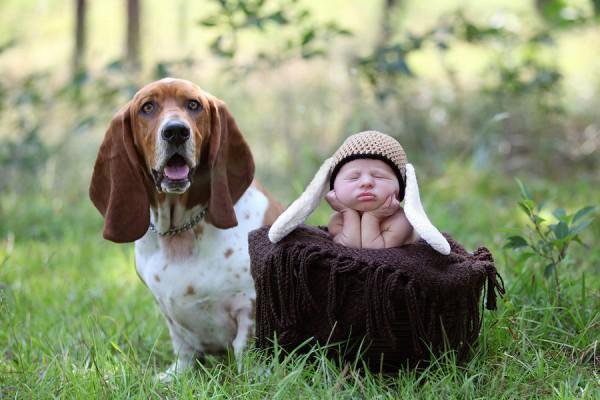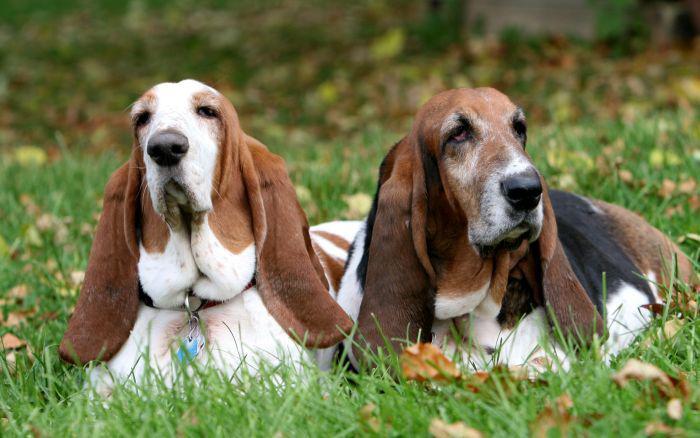The first image is the image on the left, the second image is the image on the right. Analyze the images presented: Is the assertion "All dogs are in the grass." valid? Answer yes or no. Yes. The first image is the image on the left, the second image is the image on the right. Evaluate the accuracy of this statement regarding the images: "One of the image shows only basset hounds, while the other shows a human with at least one basset hound.". Is it true? Answer yes or no. Yes. The first image is the image on the left, the second image is the image on the right. Evaluate the accuracy of this statement regarding the images: "The right image shows side-by-side basset hounds posed in the grass, and the left image shows one human posed in the grass with at least one basset hound.". Is it true? Answer yes or no. Yes. The first image is the image on the left, the second image is the image on the right. Analyze the images presented: Is the assertion "There is one image that includes a number of basset hounds that is now two." valid? Answer yes or no. Yes. 